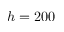<formula> <loc_0><loc_0><loc_500><loc_500>h = 2 0 0</formula> 